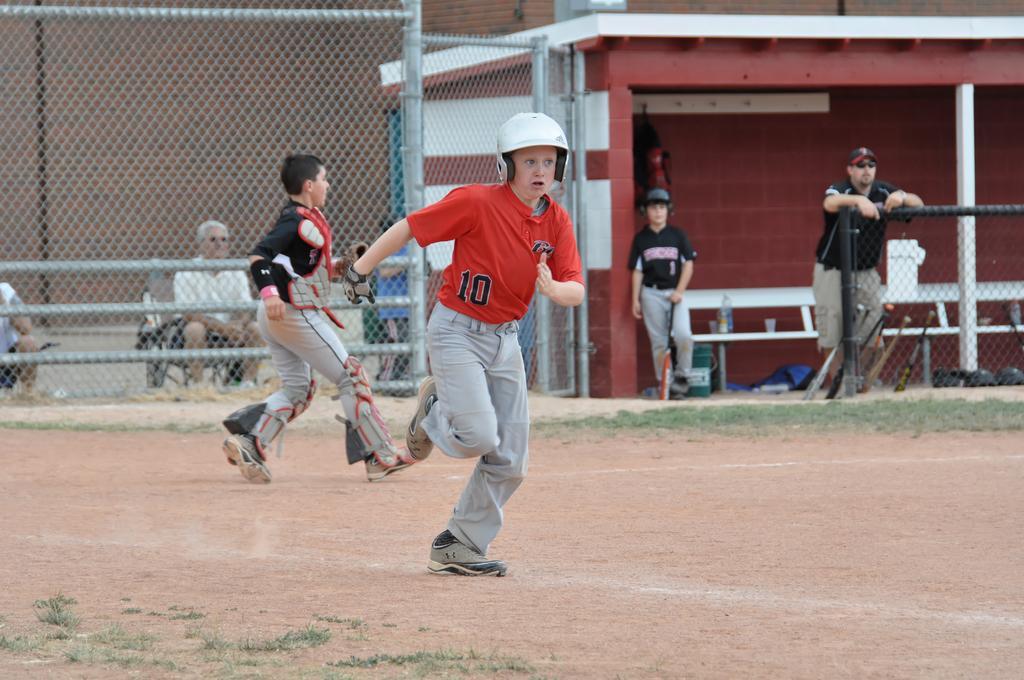In one or two sentences, can you explain what this image depicts? In this picture we can see group of people, few are sitting, few are standing and few are running, in the background we can see fence and a boy, he is holding a bat. 